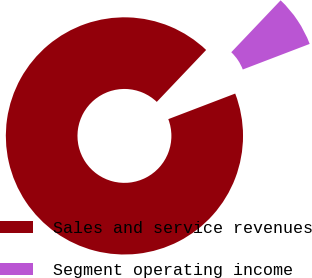Convert chart to OTSL. <chart><loc_0><loc_0><loc_500><loc_500><pie_chart><fcel>Sales and service revenues<fcel>Segment operating income<nl><fcel>92.91%<fcel>7.09%<nl></chart> 